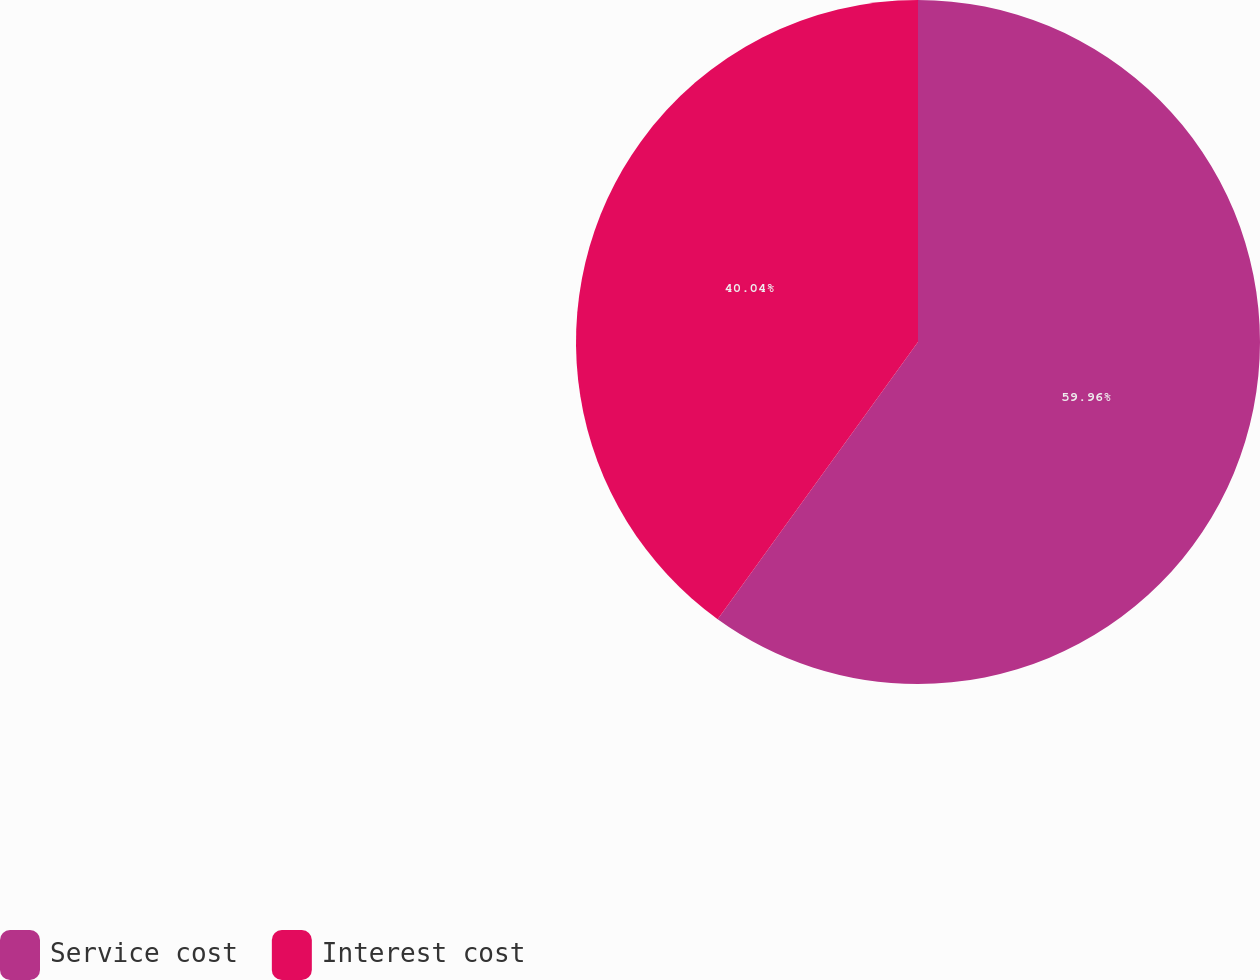<chart> <loc_0><loc_0><loc_500><loc_500><pie_chart><fcel>Service cost<fcel>Interest cost<nl><fcel>59.96%<fcel>40.04%<nl></chart> 